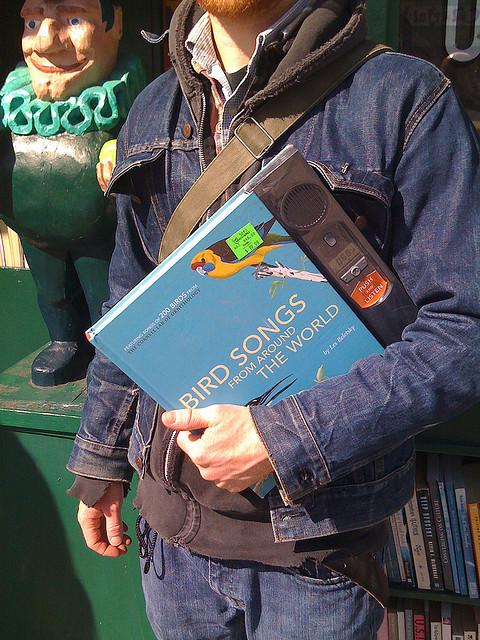What is the title of the book that is being held?
Be succinct. Bird songs. At what type of store is this person shopping?
Be succinct. Bookstore. What figure is depicted on the carved statue in the background?
Concise answer only. Leprechaun. 